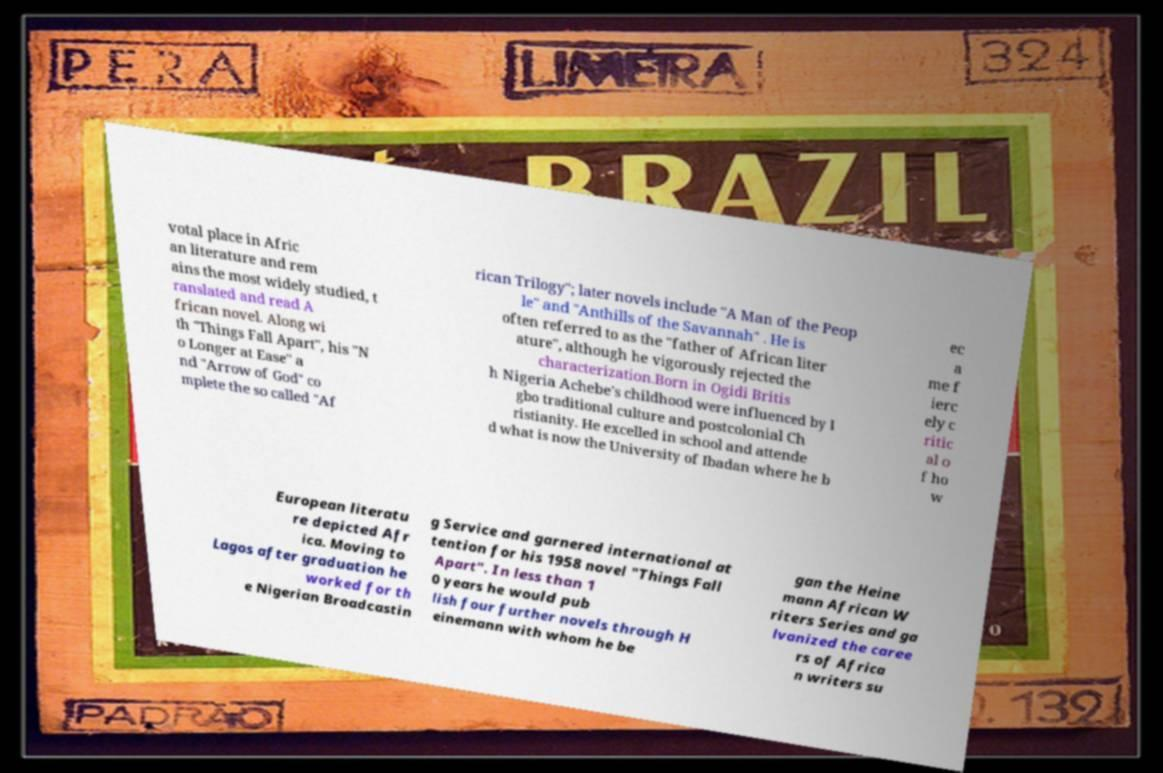Could you extract and type out the text from this image? votal place in Afric an literature and rem ains the most widely studied, t ranslated and read A frican novel. Along wi th "Things Fall Apart", his "N o Longer at Ease" a nd "Arrow of God" co mplete the so called "Af rican Trilogy"; later novels include "A Man of the Peop le" and "Anthills of the Savannah" . He is often referred to as the "father of African liter ature", although he vigorously rejected the characterization.Born in Ogidi Britis h Nigeria Achebe's childhood were influenced by I gbo traditional culture and postcolonial Ch ristianity. He excelled in school and attende d what is now the University of Ibadan where he b ec a me f ierc ely c ritic al o f ho w European literatu re depicted Afr ica. Moving to Lagos after graduation he worked for th e Nigerian Broadcastin g Service and garnered international at tention for his 1958 novel "Things Fall Apart". In less than 1 0 years he would pub lish four further novels through H einemann with whom he be gan the Heine mann African W riters Series and ga lvanized the caree rs of Africa n writers su 